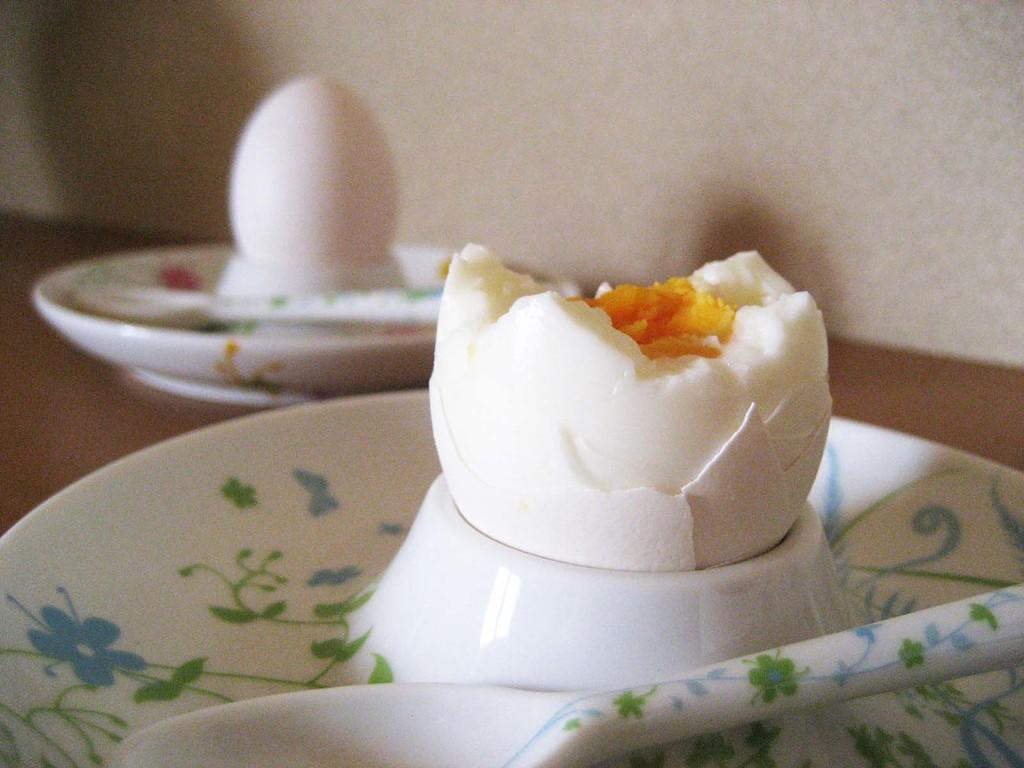What type of food item is present in the image? There are eggs in the image. What utensils can be seen in the image? There are spoons in the image. How are the eggs and spoons arranged in the image? The eggs and spoons are in plates. What type of board game is being played with the eggs and spoons in the image? There is no board game present in the image; it only features eggs and spoons in plates. What type of fiction story is being told using the eggs and spoons in the image? There is no fiction story being told using the eggs and spoons in the image; they are simply food items and utensils. 